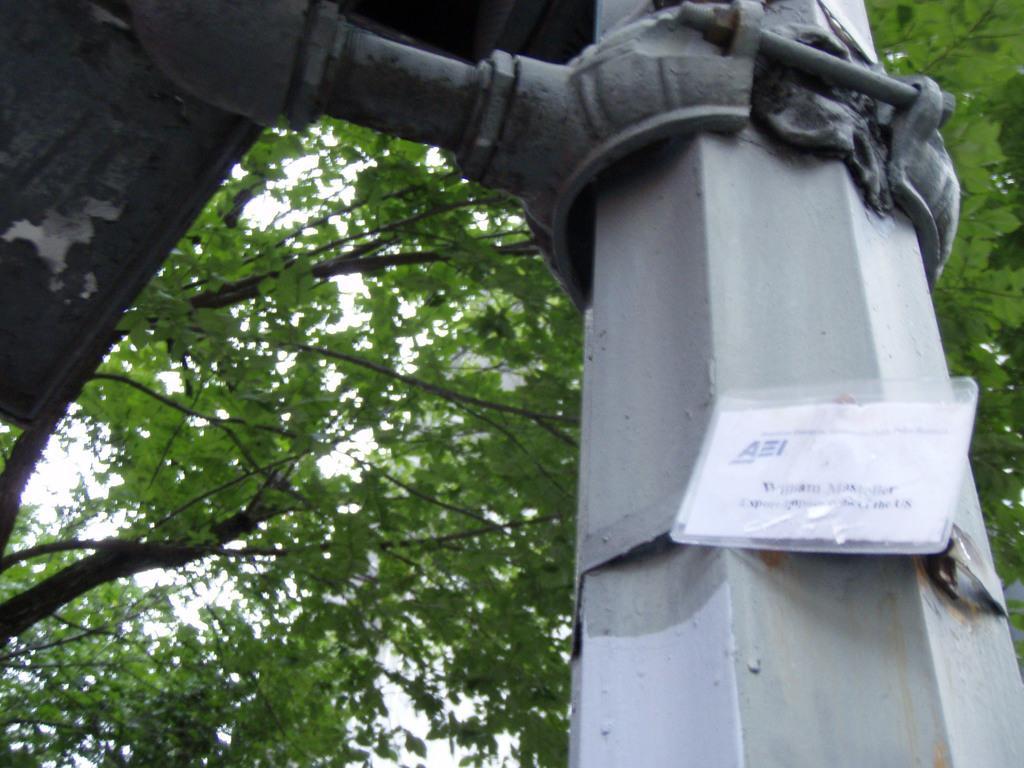Describe this image in one or two sentences. In this image in the front there is a pole and on the pole there is a paper with some text written on it. In the background there are trees and on the top left of the image there is a metal object. 